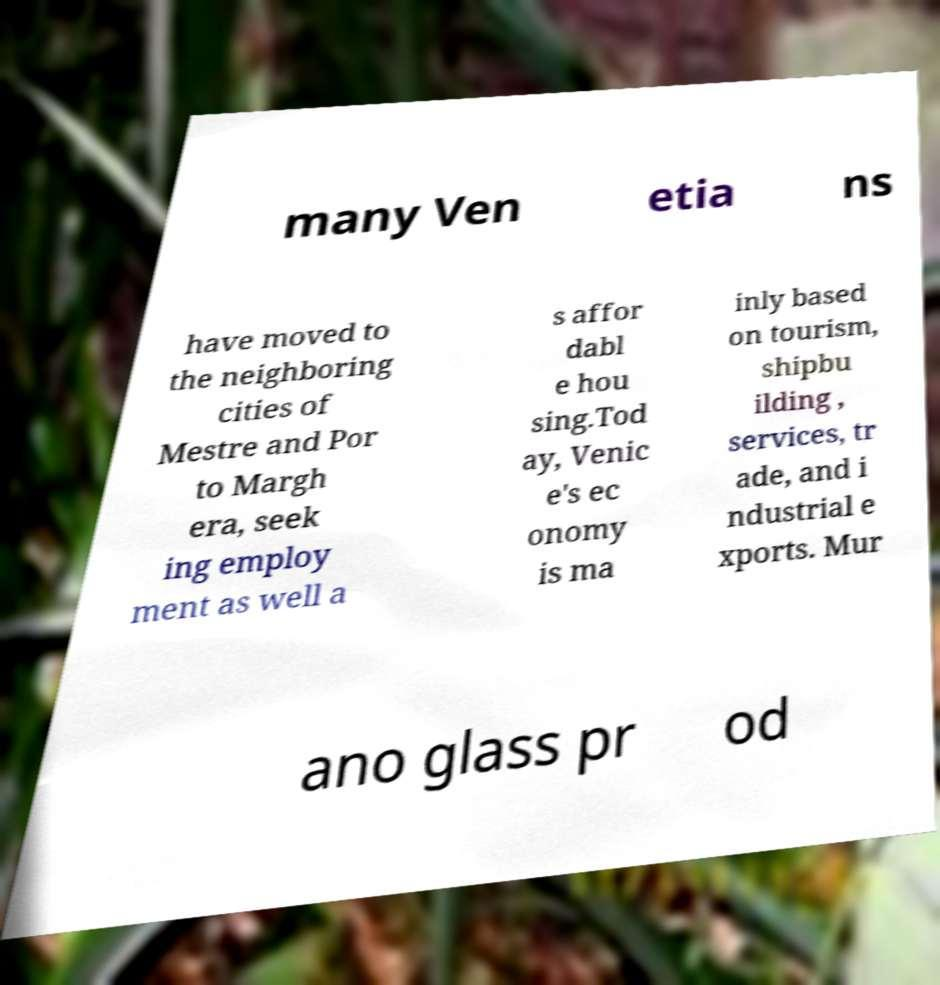Can you accurately transcribe the text from the provided image for me? many Ven etia ns have moved to the neighboring cities of Mestre and Por to Margh era, seek ing employ ment as well a s affor dabl e hou sing.Tod ay, Venic e's ec onomy is ma inly based on tourism, shipbu ilding , services, tr ade, and i ndustrial e xports. Mur ano glass pr od 